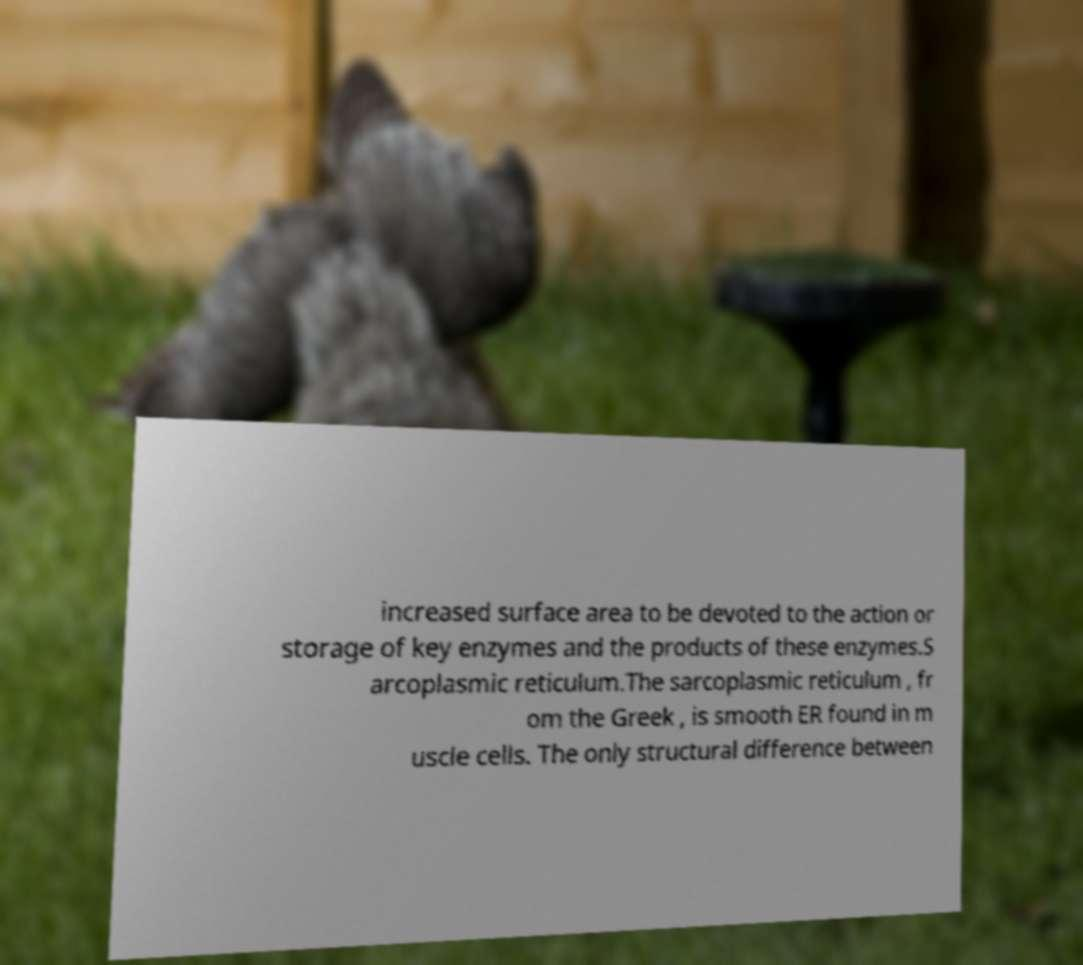There's text embedded in this image that I need extracted. Can you transcribe it verbatim? increased surface area to be devoted to the action or storage of key enzymes and the products of these enzymes.S arcoplasmic reticulum.The sarcoplasmic reticulum , fr om the Greek , is smooth ER found in m uscle cells. The only structural difference between 